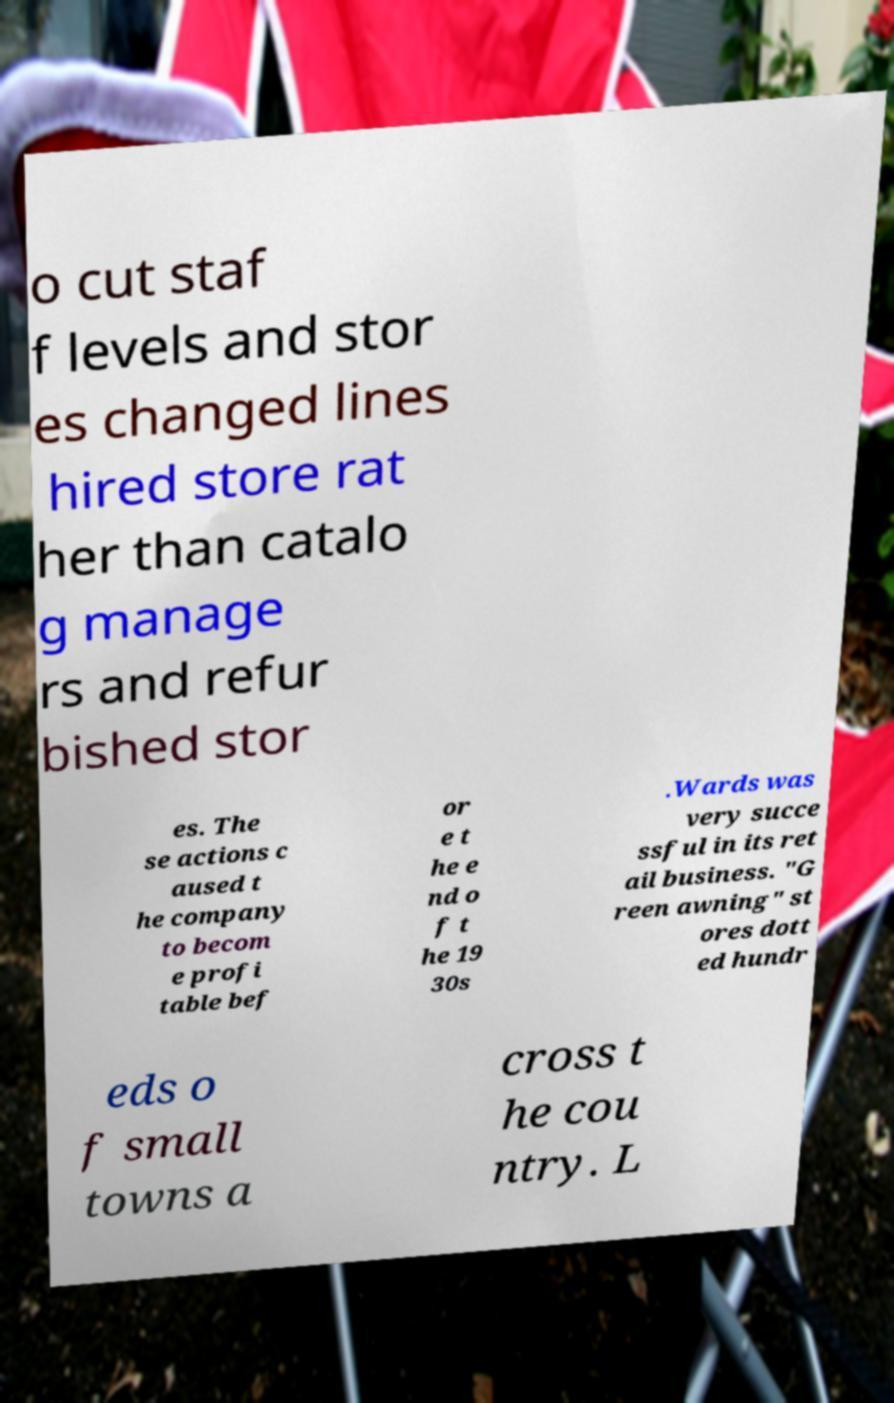What messages or text are displayed in this image? I need them in a readable, typed format. o cut staf f levels and stor es changed lines hired store rat her than catalo g manage rs and refur bished stor es. The se actions c aused t he company to becom e profi table bef or e t he e nd o f t he 19 30s .Wards was very succe ssful in its ret ail business. "G reen awning" st ores dott ed hundr eds o f small towns a cross t he cou ntry. L 